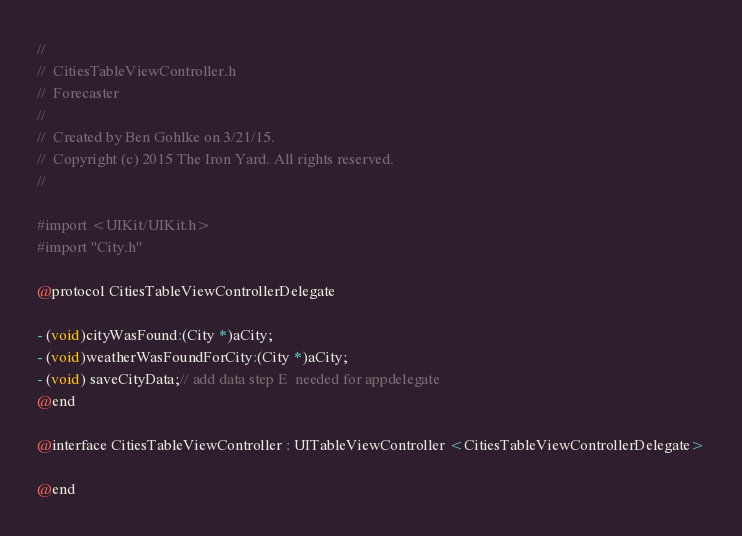Convert code to text. <code><loc_0><loc_0><loc_500><loc_500><_C_>//
//  CitiesTableViewController.h
//  Forecaster
//
//  Created by Ben Gohlke on 3/21/15.
//  Copyright (c) 2015 The Iron Yard. All rights reserved.
//

#import <UIKit/UIKit.h>
#import "City.h"

@protocol CitiesTableViewControllerDelegate

- (void)cityWasFound:(City *)aCity;
- (void)weatherWasFoundForCity:(City *)aCity;
- (void) saveCityData;// add data step E  needed for appdelegate
@end

@interface CitiesTableViewController : UITableViewController <CitiesTableViewControllerDelegate>

@end
</code> 